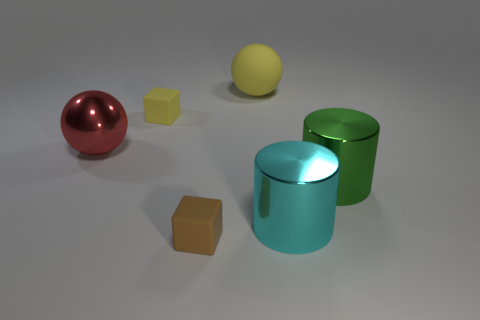Add 4 large shiny things. How many objects exist? 10 Subtract all cubes. How many objects are left? 4 Subtract all large gray metal blocks. Subtract all cyan cylinders. How many objects are left? 5 Add 3 large green metallic cylinders. How many large green metallic cylinders are left? 4 Add 5 large red objects. How many large red objects exist? 6 Subtract 1 brown cubes. How many objects are left? 5 